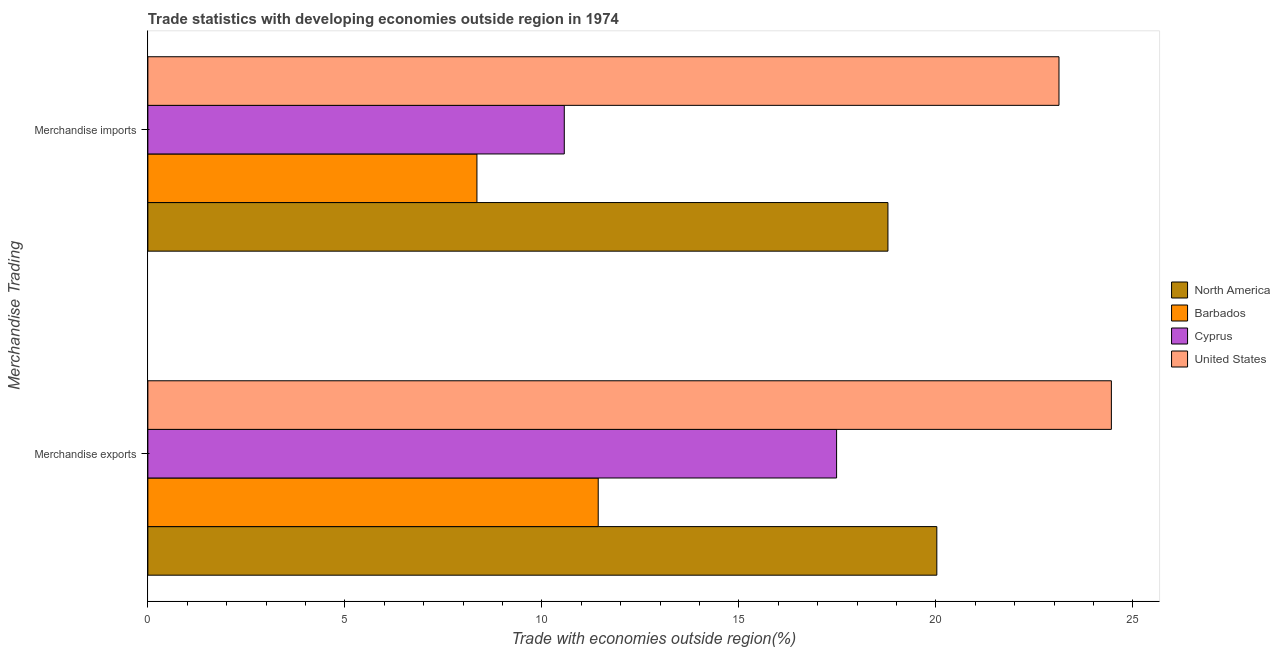Are the number of bars on each tick of the Y-axis equal?
Give a very brief answer. Yes. How many bars are there on the 2nd tick from the top?
Keep it short and to the point. 4. What is the label of the 1st group of bars from the top?
Give a very brief answer. Merchandise imports. What is the merchandise exports in North America?
Give a very brief answer. 20.02. Across all countries, what is the maximum merchandise exports?
Offer a terse response. 24.45. Across all countries, what is the minimum merchandise imports?
Keep it short and to the point. 8.35. In which country was the merchandise exports minimum?
Make the answer very short. Barbados. What is the total merchandise imports in the graph?
Offer a terse response. 60.82. What is the difference between the merchandise imports in United States and that in North America?
Keep it short and to the point. 4.34. What is the difference between the merchandise imports in Cyprus and the merchandise exports in Barbados?
Provide a succinct answer. -0.86. What is the average merchandise exports per country?
Ensure brevity in your answer.  18.35. What is the difference between the merchandise imports and merchandise exports in Cyprus?
Provide a short and direct response. -6.91. What is the ratio of the merchandise imports in Barbados to that in United States?
Your response must be concise. 0.36. In how many countries, is the merchandise imports greater than the average merchandise imports taken over all countries?
Keep it short and to the point. 2. What does the 4th bar from the top in Merchandise imports represents?
Keep it short and to the point. North America. What does the 3rd bar from the bottom in Merchandise imports represents?
Keep it short and to the point. Cyprus. How many bars are there?
Your answer should be very brief. 8. Are all the bars in the graph horizontal?
Your answer should be compact. Yes. How many countries are there in the graph?
Provide a succinct answer. 4. Are the values on the major ticks of X-axis written in scientific E-notation?
Give a very brief answer. No. Does the graph contain any zero values?
Provide a short and direct response. No. How many legend labels are there?
Ensure brevity in your answer.  4. What is the title of the graph?
Your answer should be compact. Trade statistics with developing economies outside region in 1974. Does "Romania" appear as one of the legend labels in the graph?
Keep it short and to the point. No. What is the label or title of the X-axis?
Provide a succinct answer. Trade with economies outside region(%). What is the label or title of the Y-axis?
Provide a short and direct response. Merchandise Trading. What is the Trade with economies outside region(%) in North America in Merchandise exports?
Make the answer very short. 20.02. What is the Trade with economies outside region(%) of Barbados in Merchandise exports?
Make the answer very short. 11.43. What is the Trade with economies outside region(%) in Cyprus in Merchandise exports?
Provide a succinct answer. 17.48. What is the Trade with economies outside region(%) of United States in Merchandise exports?
Provide a succinct answer. 24.45. What is the Trade with economies outside region(%) in North America in Merchandise imports?
Your answer should be very brief. 18.78. What is the Trade with economies outside region(%) of Barbados in Merchandise imports?
Your answer should be very brief. 8.35. What is the Trade with economies outside region(%) of Cyprus in Merchandise imports?
Make the answer very short. 10.57. What is the Trade with economies outside region(%) of United States in Merchandise imports?
Keep it short and to the point. 23.12. Across all Merchandise Trading, what is the maximum Trade with economies outside region(%) in North America?
Your answer should be very brief. 20.02. Across all Merchandise Trading, what is the maximum Trade with economies outside region(%) in Barbados?
Keep it short and to the point. 11.43. Across all Merchandise Trading, what is the maximum Trade with economies outside region(%) in Cyprus?
Make the answer very short. 17.48. Across all Merchandise Trading, what is the maximum Trade with economies outside region(%) in United States?
Offer a very short reply. 24.45. Across all Merchandise Trading, what is the minimum Trade with economies outside region(%) in North America?
Ensure brevity in your answer.  18.78. Across all Merchandise Trading, what is the minimum Trade with economies outside region(%) in Barbados?
Make the answer very short. 8.35. Across all Merchandise Trading, what is the minimum Trade with economies outside region(%) of Cyprus?
Your answer should be very brief. 10.57. Across all Merchandise Trading, what is the minimum Trade with economies outside region(%) in United States?
Make the answer very short. 23.12. What is the total Trade with economies outside region(%) in North America in the graph?
Your response must be concise. 38.8. What is the total Trade with economies outside region(%) in Barbados in the graph?
Give a very brief answer. 19.78. What is the total Trade with economies outside region(%) in Cyprus in the graph?
Make the answer very short. 28.05. What is the total Trade with economies outside region(%) of United States in the graph?
Provide a succinct answer. 47.57. What is the difference between the Trade with economies outside region(%) in North America in Merchandise exports and that in Merchandise imports?
Offer a terse response. 1.24. What is the difference between the Trade with economies outside region(%) in Barbados in Merchandise exports and that in Merchandise imports?
Your answer should be very brief. 3.08. What is the difference between the Trade with economies outside region(%) in Cyprus in Merchandise exports and that in Merchandise imports?
Make the answer very short. 6.91. What is the difference between the Trade with economies outside region(%) of United States in Merchandise exports and that in Merchandise imports?
Offer a very short reply. 1.33. What is the difference between the Trade with economies outside region(%) in North America in Merchandise exports and the Trade with economies outside region(%) in Barbados in Merchandise imports?
Give a very brief answer. 11.67. What is the difference between the Trade with economies outside region(%) of North America in Merchandise exports and the Trade with economies outside region(%) of Cyprus in Merchandise imports?
Keep it short and to the point. 9.45. What is the difference between the Trade with economies outside region(%) of North America in Merchandise exports and the Trade with economies outside region(%) of United States in Merchandise imports?
Your answer should be very brief. -3.1. What is the difference between the Trade with economies outside region(%) of Barbados in Merchandise exports and the Trade with economies outside region(%) of Cyprus in Merchandise imports?
Offer a terse response. 0.86. What is the difference between the Trade with economies outside region(%) of Barbados in Merchandise exports and the Trade with economies outside region(%) of United States in Merchandise imports?
Provide a short and direct response. -11.69. What is the difference between the Trade with economies outside region(%) of Cyprus in Merchandise exports and the Trade with economies outside region(%) of United States in Merchandise imports?
Give a very brief answer. -5.64. What is the average Trade with economies outside region(%) in North America per Merchandise Trading?
Make the answer very short. 19.4. What is the average Trade with economies outside region(%) of Barbados per Merchandise Trading?
Offer a very short reply. 9.89. What is the average Trade with economies outside region(%) in Cyprus per Merchandise Trading?
Your answer should be very brief. 14.02. What is the average Trade with economies outside region(%) in United States per Merchandise Trading?
Your response must be concise. 23.79. What is the difference between the Trade with economies outside region(%) of North America and Trade with economies outside region(%) of Barbados in Merchandise exports?
Keep it short and to the point. 8.59. What is the difference between the Trade with economies outside region(%) of North America and Trade with economies outside region(%) of Cyprus in Merchandise exports?
Provide a succinct answer. 2.54. What is the difference between the Trade with economies outside region(%) in North America and Trade with economies outside region(%) in United States in Merchandise exports?
Make the answer very short. -4.43. What is the difference between the Trade with economies outside region(%) of Barbados and Trade with economies outside region(%) of Cyprus in Merchandise exports?
Your answer should be compact. -6.05. What is the difference between the Trade with economies outside region(%) in Barbados and Trade with economies outside region(%) in United States in Merchandise exports?
Give a very brief answer. -13.02. What is the difference between the Trade with economies outside region(%) of Cyprus and Trade with economies outside region(%) of United States in Merchandise exports?
Your response must be concise. -6.97. What is the difference between the Trade with economies outside region(%) of North America and Trade with economies outside region(%) of Barbados in Merchandise imports?
Offer a terse response. 10.43. What is the difference between the Trade with economies outside region(%) in North America and Trade with economies outside region(%) in Cyprus in Merchandise imports?
Your answer should be very brief. 8.21. What is the difference between the Trade with economies outside region(%) in North America and Trade with economies outside region(%) in United States in Merchandise imports?
Your answer should be compact. -4.34. What is the difference between the Trade with economies outside region(%) in Barbados and Trade with economies outside region(%) in Cyprus in Merchandise imports?
Keep it short and to the point. -2.22. What is the difference between the Trade with economies outside region(%) of Barbados and Trade with economies outside region(%) of United States in Merchandise imports?
Provide a short and direct response. -14.77. What is the difference between the Trade with economies outside region(%) in Cyprus and Trade with economies outside region(%) in United States in Merchandise imports?
Offer a terse response. -12.55. What is the ratio of the Trade with economies outside region(%) in North America in Merchandise exports to that in Merchandise imports?
Your answer should be compact. 1.07. What is the ratio of the Trade with economies outside region(%) in Barbados in Merchandise exports to that in Merchandise imports?
Offer a terse response. 1.37. What is the ratio of the Trade with economies outside region(%) of Cyprus in Merchandise exports to that in Merchandise imports?
Provide a short and direct response. 1.65. What is the ratio of the Trade with economies outside region(%) of United States in Merchandise exports to that in Merchandise imports?
Offer a terse response. 1.06. What is the difference between the highest and the second highest Trade with economies outside region(%) in North America?
Make the answer very short. 1.24. What is the difference between the highest and the second highest Trade with economies outside region(%) of Barbados?
Offer a terse response. 3.08. What is the difference between the highest and the second highest Trade with economies outside region(%) in Cyprus?
Ensure brevity in your answer.  6.91. What is the difference between the highest and the second highest Trade with economies outside region(%) of United States?
Offer a terse response. 1.33. What is the difference between the highest and the lowest Trade with economies outside region(%) in North America?
Offer a very short reply. 1.24. What is the difference between the highest and the lowest Trade with economies outside region(%) of Barbados?
Keep it short and to the point. 3.08. What is the difference between the highest and the lowest Trade with economies outside region(%) of Cyprus?
Your answer should be very brief. 6.91. What is the difference between the highest and the lowest Trade with economies outside region(%) in United States?
Make the answer very short. 1.33. 